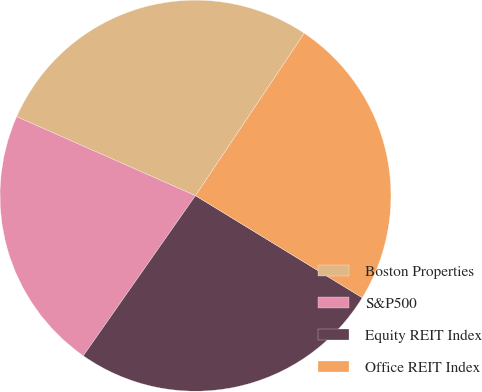Convert chart to OTSL. <chart><loc_0><loc_0><loc_500><loc_500><pie_chart><fcel>Boston Properties<fcel>S&P500<fcel>Equity REIT Index<fcel>Office REIT Index<nl><fcel>27.77%<fcel>21.9%<fcel>25.99%<fcel>24.35%<nl></chart> 